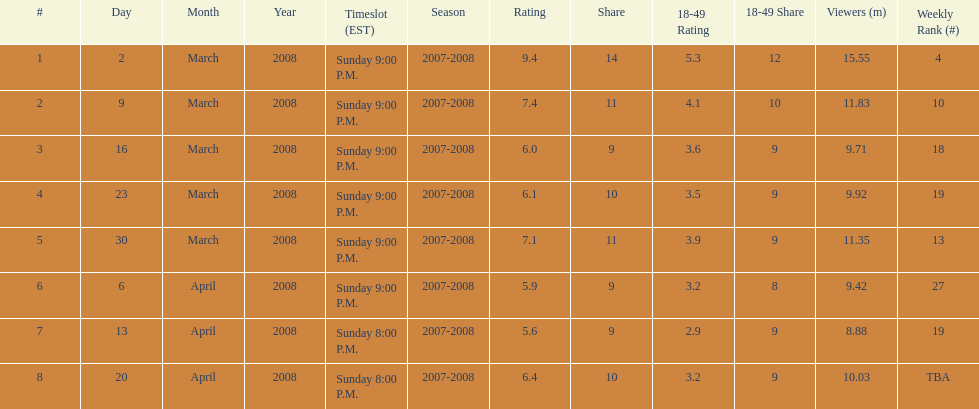The air date with the most viewers March 2, 2008. 